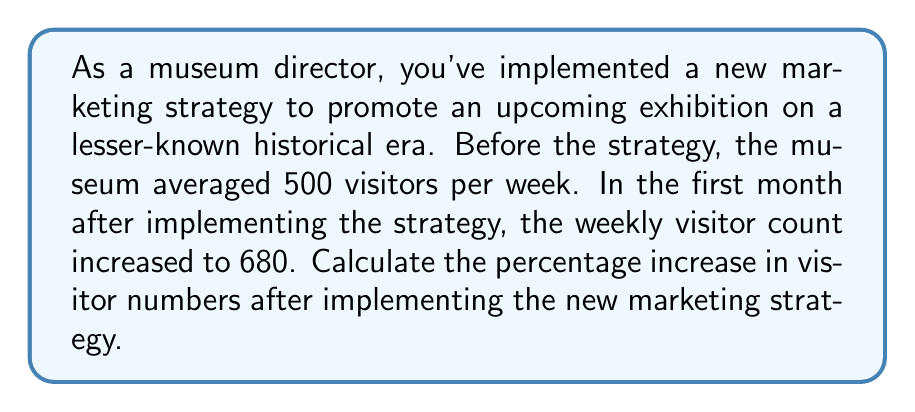Show me your answer to this math problem. To calculate the percentage increase in visitor numbers, we need to follow these steps:

1. Calculate the difference between the new and original visitor numbers:
   $\text{Increase} = \text{New visitors} - \text{Original visitors}$
   $\text{Increase} = 680 - 500 = 180$

2. Divide the increase by the original number of visitors:
   $\text{Fraction of increase} = \frac{\text{Increase}}{\text{Original visitors}} = \frac{180}{500} = 0.36$

3. Convert the fraction to a percentage by multiplying by 100:
   $\text{Percentage increase} = \text{Fraction of increase} \times 100\%$
   $\text{Percentage increase} = 0.36 \times 100\% = 36\%$

Therefore, the percentage increase in visitor numbers after implementing the new marketing strategy is 36%.

We can verify this result using the percentage increase formula:

$$\text{Percentage increase} = \frac{\text{New value} - \text{Original value}}{\text{Original value}} \times 100\%$$

$$\text{Percentage increase} = \frac{680 - 500}{500} \times 100\% = \frac{180}{500} \times 100\% = 0.36 \times 100\% = 36\%$$
Answer: The percentage increase in visitor numbers after implementing the new marketing strategy is 36%. 